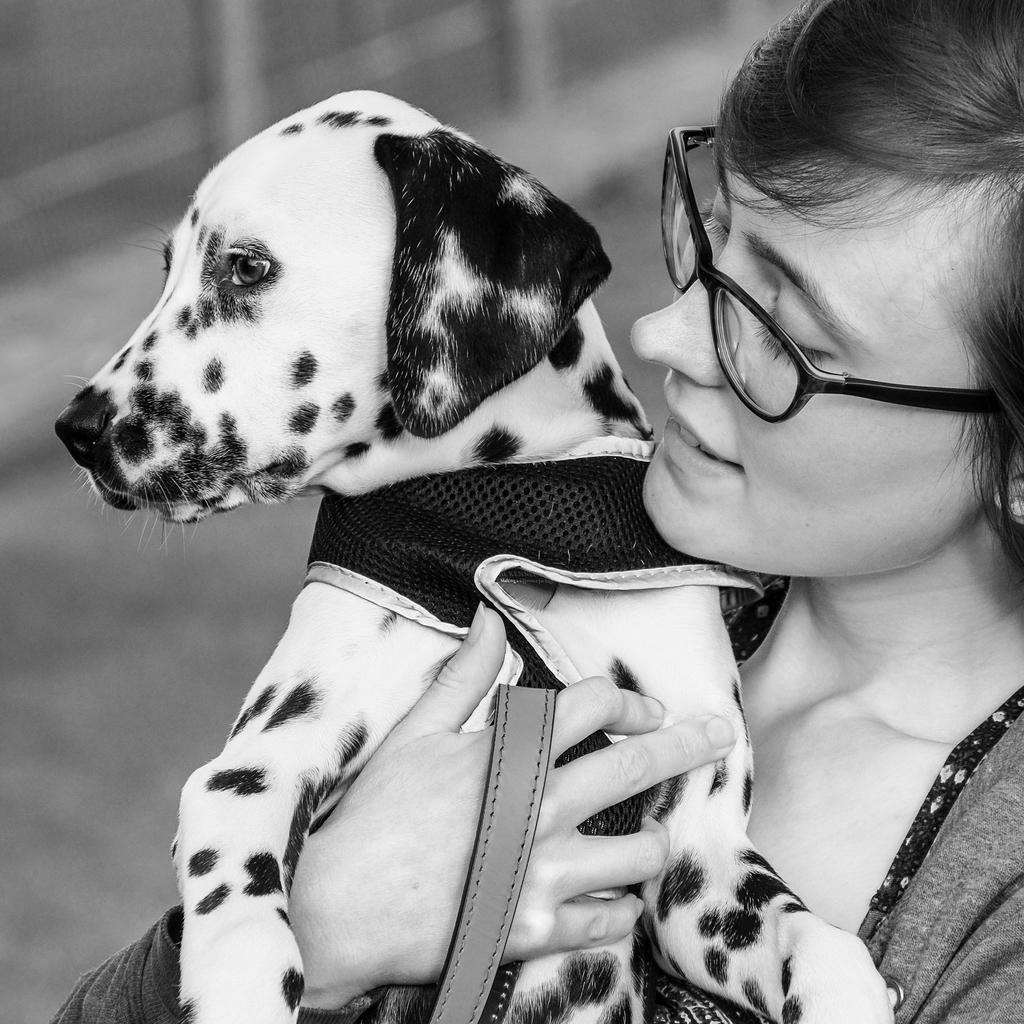What is the main subject of the image? The main subject of the image is a woman. What is the woman doing in the image? The woman is holding a dog in the image. What accessory is the woman wearing? The woman is wearing spectacles in the image. What is the color scheme of the image? The image is black and white. Can you see any rings on the woman's fingers in the image? There is no mention of rings in the provided facts, and therefore it cannot be determined if the woman is wearing any rings in the image. Is there a railway visible in the image? There is no mention of a railway in the provided facts, and therefore it cannot be determined if a railway is present in the image. 